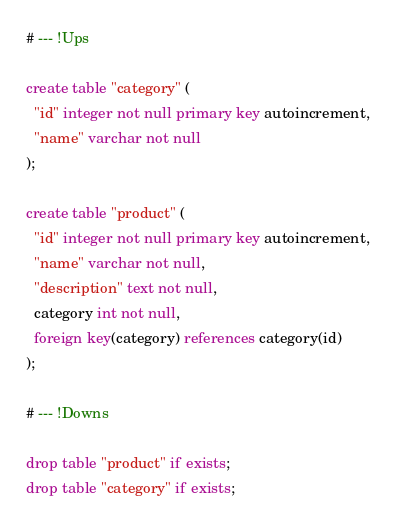Convert code to text. <code><loc_0><loc_0><loc_500><loc_500><_SQL_># --- !Ups

create table "category" (
  "id" integer not null primary key autoincrement,
  "name" varchar not null
);

create table "product" (
  "id" integer not null primary key autoincrement,
  "name" varchar not null,
  "description" text not null,
  category int not null,
  foreign key(category) references category(id)
);

# --- !Downs

drop table "product" if exists;
drop table "category" if exists;</code> 